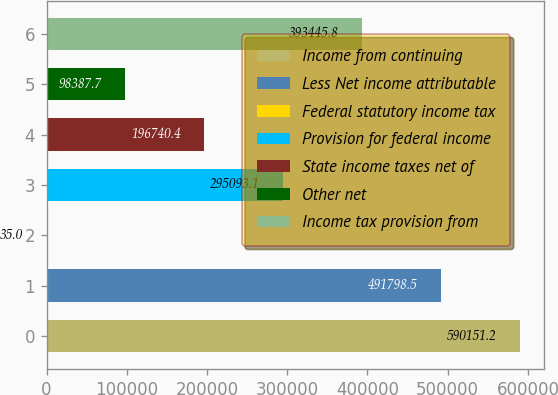Convert chart to OTSL. <chart><loc_0><loc_0><loc_500><loc_500><bar_chart><fcel>Income from continuing<fcel>Less Net income attributable<fcel>Federal statutory income tax<fcel>Provision for federal income<fcel>State income taxes net of<fcel>Other net<fcel>Income tax provision from<nl><fcel>590151<fcel>491798<fcel>35<fcel>295093<fcel>196740<fcel>98387.7<fcel>393446<nl></chart> 